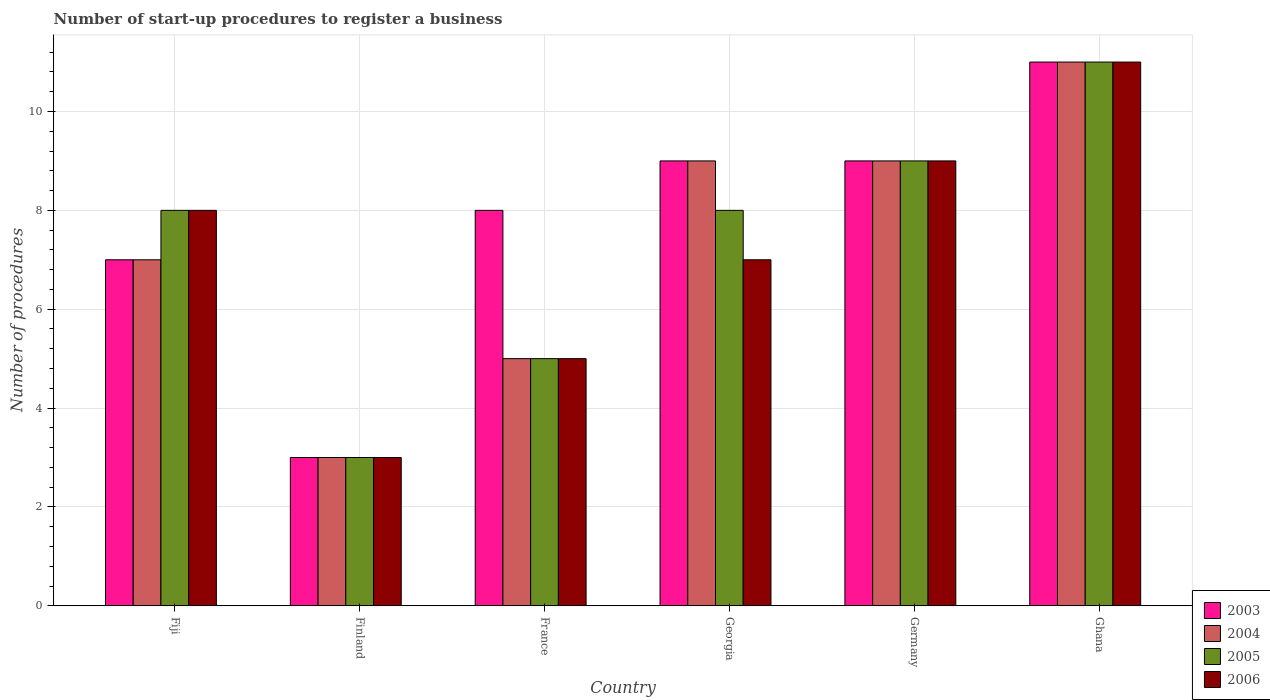How many groups of bars are there?
Offer a very short reply. 6. Are the number of bars per tick equal to the number of legend labels?
Give a very brief answer. Yes. What is the number of procedures required to register a business in 2004 in France?
Provide a short and direct response. 5. In which country was the number of procedures required to register a business in 2003 minimum?
Offer a very short reply. Finland. What is the total number of procedures required to register a business in 2006 in the graph?
Provide a succinct answer. 43. What is the difference between the number of procedures required to register a business in 2006 in Germany and the number of procedures required to register a business in 2003 in Fiji?
Give a very brief answer. 2. What is the average number of procedures required to register a business in 2003 per country?
Your response must be concise. 7.83. What is the difference between the number of procedures required to register a business of/in 2004 and number of procedures required to register a business of/in 2003 in Georgia?
Ensure brevity in your answer.  0. In how many countries, is the number of procedures required to register a business in 2006 greater than 0.8?
Your response must be concise. 6. What is the ratio of the number of procedures required to register a business in 2006 in Fiji to that in Germany?
Keep it short and to the point. 0.89. Is the number of procedures required to register a business in 2005 in Fiji less than that in Germany?
Offer a terse response. Yes. What is the difference between the highest and the lowest number of procedures required to register a business in 2005?
Provide a succinct answer. 8. Is the sum of the number of procedures required to register a business in 2006 in France and Georgia greater than the maximum number of procedures required to register a business in 2003 across all countries?
Keep it short and to the point. Yes. Is it the case that in every country, the sum of the number of procedures required to register a business in 2006 and number of procedures required to register a business in 2003 is greater than the sum of number of procedures required to register a business in 2004 and number of procedures required to register a business in 2005?
Keep it short and to the point. No. What does the 2nd bar from the left in Germany represents?
Make the answer very short. 2004. How many bars are there?
Make the answer very short. 24. What is the difference between two consecutive major ticks on the Y-axis?
Give a very brief answer. 2. Are the values on the major ticks of Y-axis written in scientific E-notation?
Give a very brief answer. No. How many legend labels are there?
Your response must be concise. 4. How are the legend labels stacked?
Provide a short and direct response. Vertical. What is the title of the graph?
Your response must be concise. Number of start-up procedures to register a business. Does "1968" appear as one of the legend labels in the graph?
Offer a terse response. No. What is the label or title of the Y-axis?
Your answer should be very brief. Number of procedures. What is the Number of procedures of 2003 in Fiji?
Your response must be concise. 7. What is the Number of procedures of 2006 in Fiji?
Give a very brief answer. 8. What is the Number of procedures of 2004 in Finland?
Your response must be concise. 3. What is the Number of procedures in 2003 in France?
Offer a very short reply. 8. What is the Number of procedures in 2004 in France?
Give a very brief answer. 5. What is the Number of procedures of 2005 in France?
Your answer should be very brief. 5. What is the Number of procedures in 2005 in Georgia?
Your response must be concise. 8. What is the Number of procedures of 2006 in Georgia?
Offer a terse response. 7. What is the Number of procedures in 2004 in Germany?
Provide a succinct answer. 9. What is the Number of procedures in 2003 in Ghana?
Your answer should be compact. 11. Across all countries, what is the maximum Number of procedures of 2003?
Offer a terse response. 11. Across all countries, what is the maximum Number of procedures in 2005?
Your answer should be very brief. 11. Across all countries, what is the maximum Number of procedures of 2006?
Provide a short and direct response. 11. Across all countries, what is the minimum Number of procedures in 2003?
Provide a short and direct response. 3. Across all countries, what is the minimum Number of procedures in 2004?
Your answer should be very brief. 3. Across all countries, what is the minimum Number of procedures of 2005?
Keep it short and to the point. 3. Across all countries, what is the minimum Number of procedures of 2006?
Your response must be concise. 3. What is the total Number of procedures in 2006 in the graph?
Ensure brevity in your answer.  43. What is the difference between the Number of procedures in 2004 in Fiji and that in Finland?
Give a very brief answer. 4. What is the difference between the Number of procedures of 2005 in Fiji and that in Finland?
Keep it short and to the point. 5. What is the difference between the Number of procedures in 2006 in Fiji and that in Finland?
Your answer should be compact. 5. What is the difference between the Number of procedures in 2004 in Fiji and that in France?
Your answer should be very brief. 2. What is the difference between the Number of procedures of 2005 in Fiji and that in France?
Provide a short and direct response. 3. What is the difference between the Number of procedures in 2006 in Fiji and that in France?
Ensure brevity in your answer.  3. What is the difference between the Number of procedures of 2004 in Fiji and that in Georgia?
Your response must be concise. -2. What is the difference between the Number of procedures of 2006 in Fiji and that in Georgia?
Keep it short and to the point. 1. What is the difference between the Number of procedures in 2005 in Fiji and that in Germany?
Your answer should be compact. -1. What is the difference between the Number of procedures of 2004 in Fiji and that in Ghana?
Keep it short and to the point. -4. What is the difference between the Number of procedures of 2005 in Fiji and that in Ghana?
Offer a terse response. -3. What is the difference between the Number of procedures in 2004 in Finland and that in France?
Keep it short and to the point. -2. What is the difference between the Number of procedures of 2005 in Finland and that in France?
Offer a very short reply. -2. What is the difference between the Number of procedures in 2003 in Finland and that in Georgia?
Provide a short and direct response. -6. What is the difference between the Number of procedures in 2005 in Finland and that in Georgia?
Ensure brevity in your answer.  -5. What is the difference between the Number of procedures of 2006 in Finland and that in Georgia?
Offer a terse response. -4. What is the difference between the Number of procedures of 2003 in Finland and that in Germany?
Provide a succinct answer. -6. What is the difference between the Number of procedures in 2004 in Finland and that in Ghana?
Offer a very short reply. -8. What is the difference between the Number of procedures in 2003 in France and that in Georgia?
Give a very brief answer. -1. What is the difference between the Number of procedures in 2004 in France and that in Georgia?
Ensure brevity in your answer.  -4. What is the difference between the Number of procedures of 2005 in France and that in Georgia?
Provide a short and direct response. -3. What is the difference between the Number of procedures of 2004 in France and that in Germany?
Your answer should be very brief. -4. What is the difference between the Number of procedures in 2006 in France and that in Germany?
Ensure brevity in your answer.  -4. What is the difference between the Number of procedures of 2003 in France and that in Ghana?
Ensure brevity in your answer.  -3. What is the difference between the Number of procedures of 2004 in France and that in Ghana?
Ensure brevity in your answer.  -6. What is the difference between the Number of procedures in 2005 in France and that in Ghana?
Offer a very short reply. -6. What is the difference between the Number of procedures in 2006 in France and that in Ghana?
Keep it short and to the point. -6. What is the difference between the Number of procedures in 2003 in Georgia and that in Germany?
Give a very brief answer. 0. What is the difference between the Number of procedures in 2005 in Georgia and that in Germany?
Give a very brief answer. -1. What is the difference between the Number of procedures of 2006 in Georgia and that in Germany?
Ensure brevity in your answer.  -2. What is the difference between the Number of procedures of 2003 in Georgia and that in Ghana?
Provide a short and direct response. -2. What is the difference between the Number of procedures in 2004 in Georgia and that in Ghana?
Ensure brevity in your answer.  -2. What is the difference between the Number of procedures in 2004 in Germany and that in Ghana?
Your answer should be compact. -2. What is the difference between the Number of procedures of 2005 in Germany and that in Ghana?
Provide a succinct answer. -2. What is the difference between the Number of procedures in 2003 in Fiji and the Number of procedures in 2004 in Finland?
Provide a succinct answer. 4. What is the difference between the Number of procedures of 2003 in Fiji and the Number of procedures of 2005 in Finland?
Your answer should be compact. 4. What is the difference between the Number of procedures in 2004 in Fiji and the Number of procedures in 2005 in Finland?
Give a very brief answer. 4. What is the difference between the Number of procedures of 2004 in Fiji and the Number of procedures of 2006 in Finland?
Your answer should be compact. 4. What is the difference between the Number of procedures of 2003 in Fiji and the Number of procedures of 2004 in France?
Keep it short and to the point. 2. What is the difference between the Number of procedures in 2003 in Fiji and the Number of procedures in 2006 in France?
Offer a very short reply. 2. What is the difference between the Number of procedures of 2005 in Fiji and the Number of procedures of 2006 in France?
Give a very brief answer. 3. What is the difference between the Number of procedures in 2003 in Fiji and the Number of procedures in 2004 in Georgia?
Give a very brief answer. -2. What is the difference between the Number of procedures of 2003 in Fiji and the Number of procedures of 2006 in Georgia?
Your response must be concise. 0. What is the difference between the Number of procedures in 2004 in Fiji and the Number of procedures in 2006 in Georgia?
Your answer should be compact. 0. What is the difference between the Number of procedures in 2005 in Fiji and the Number of procedures in 2006 in Georgia?
Offer a terse response. 1. What is the difference between the Number of procedures of 2003 in Fiji and the Number of procedures of 2004 in Germany?
Ensure brevity in your answer.  -2. What is the difference between the Number of procedures in 2004 in Fiji and the Number of procedures in 2005 in Germany?
Provide a short and direct response. -2. What is the difference between the Number of procedures in 2003 in Fiji and the Number of procedures in 2005 in Ghana?
Provide a succinct answer. -4. What is the difference between the Number of procedures of 2004 in Fiji and the Number of procedures of 2006 in Ghana?
Offer a very short reply. -4. What is the difference between the Number of procedures in 2004 in Finland and the Number of procedures in 2005 in Georgia?
Provide a short and direct response. -5. What is the difference between the Number of procedures of 2003 in Finland and the Number of procedures of 2006 in Germany?
Your answer should be compact. -6. What is the difference between the Number of procedures in 2004 in Finland and the Number of procedures in 2006 in Germany?
Offer a terse response. -6. What is the difference between the Number of procedures in 2003 in Finland and the Number of procedures in 2004 in Ghana?
Your answer should be compact. -8. What is the difference between the Number of procedures of 2003 in Finland and the Number of procedures of 2005 in Ghana?
Provide a succinct answer. -8. What is the difference between the Number of procedures of 2003 in Finland and the Number of procedures of 2006 in Ghana?
Offer a terse response. -8. What is the difference between the Number of procedures in 2004 in Finland and the Number of procedures in 2005 in Ghana?
Your answer should be compact. -8. What is the difference between the Number of procedures of 2005 in Finland and the Number of procedures of 2006 in Ghana?
Your answer should be compact. -8. What is the difference between the Number of procedures in 2003 in France and the Number of procedures in 2004 in Georgia?
Provide a short and direct response. -1. What is the difference between the Number of procedures in 2003 in France and the Number of procedures in 2006 in Georgia?
Your answer should be very brief. 1. What is the difference between the Number of procedures of 2004 in France and the Number of procedures of 2006 in Georgia?
Offer a very short reply. -2. What is the difference between the Number of procedures of 2003 in France and the Number of procedures of 2006 in Germany?
Provide a succinct answer. -1. What is the difference between the Number of procedures in 2004 in France and the Number of procedures in 2005 in Germany?
Offer a terse response. -4. What is the difference between the Number of procedures in 2003 in France and the Number of procedures in 2004 in Ghana?
Provide a succinct answer. -3. What is the difference between the Number of procedures in 2003 in France and the Number of procedures in 2005 in Ghana?
Offer a very short reply. -3. What is the difference between the Number of procedures in 2003 in France and the Number of procedures in 2006 in Ghana?
Offer a very short reply. -3. What is the difference between the Number of procedures in 2004 in France and the Number of procedures in 2005 in Ghana?
Give a very brief answer. -6. What is the difference between the Number of procedures of 2003 in Georgia and the Number of procedures of 2004 in Germany?
Provide a succinct answer. 0. What is the difference between the Number of procedures in 2004 in Georgia and the Number of procedures in 2006 in Germany?
Your response must be concise. 0. What is the difference between the Number of procedures of 2005 in Georgia and the Number of procedures of 2006 in Germany?
Your response must be concise. -1. What is the difference between the Number of procedures of 2003 in Georgia and the Number of procedures of 2004 in Ghana?
Your answer should be very brief. -2. What is the difference between the Number of procedures in 2005 in Georgia and the Number of procedures in 2006 in Ghana?
Your answer should be very brief. -3. What is the difference between the Number of procedures in 2003 in Germany and the Number of procedures in 2006 in Ghana?
Keep it short and to the point. -2. What is the difference between the Number of procedures of 2004 in Germany and the Number of procedures of 2006 in Ghana?
Your response must be concise. -2. What is the difference between the Number of procedures in 2005 in Germany and the Number of procedures in 2006 in Ghana?
Give a very brief answer. -2. What is the average Number of procedures of 2003 per country?
Your response must be concise. 7.83. What is the average Number of procedures of 2004 per country?
Provide a short and direct response. 7.33. What is the average Number of procedures in 2005 per country?
Provide a succinct answer. 7.33. What is the average Number of procedures in 2006 per country?
Keep it short and to the point. 7.17. What is the difference between the Number of procedures of 2003 and Number of procedures of 2004 in Fiji?
Offer a very short reply. 0. What is the difference between the Number of procedures in 2003 and Number of procedures in 2005 in Fiji?
Offer a very short reply. -1. What is the difference between the Number of procedures of 2003 and Number of procedures of 2006 in Fiji?
Offer a terse response. -1. What is the difference between the Number of procedures in 2004 and Number of procedures in 2005 in Fiji?
Offer a very short reply. -1. What is the difference between the Number of procedures in 2005 and Number of procedures in 2006 in Fiji?
Provide a short and direct response. 0. What is the difference between the Number of procedures in 2003 and Number of procedures in 2006 in Finland?
Keep it short and to the point. 0. What is the difference between the Number of procedures in 2004 and Number of procedures in 2005 in Finland?
Provide a succinct answer. 0. What is the difference between the Number of procedures of 2004 and Number of procedures of 2006 in Finland?
Keep it short and to the point. 0. What is the difference between the Number of procedures of 2005 and Number of procedures of 2006 in Finland?
Your response must be concise. 0. What is the difference between the Number of procedures in 2003 and Number of procedures in 2004 in France?
Your answer should be compact. 3. What is the difference between the Number of procedures in 2003 and Number of procedures in 2005 in France?
Ensure brevity in your answer.  3. What is the difference between the Number of procedures in 2003 and Number of procedures in 2006 in France?
Offer a terse response. 3. What is the difference between the Number of procedures in 2004 and Number of procedures in 2005 in France?
Provide a short and direct response. 0. What is the difference between the Number of procedures in 2005 and Number of procedures in 2006 in France?
Ensure brevity in your answer.  0. What is the difference between the Number of procedures in 2003 and Number of procedures in 2004 in Georgia?
Make the answer very short. 0. What is the difference between the Number of procedures of 2003 and Number of procedures of 2006 in Georgia?
Give a very brief answer. 2. What is the difference between the Number of procedures of 2004 and Number of procedures of 2005 in Georgia?
Provide a succinct answer. 1. What is the difference between the Number of procedures in 2003 and Number of procedures in 2004 in Germany?
Provide a succinct answer. 0. What is the difference between the Number of procedures of 2004 and Number of procedures of 2005 in Germany?
Your response must be concise. 0. What is the difference between the Number of procedures of 2003 and Number of procedures of 2004 in Ghana?
Make the answer very short. 0. What is the difference between the Number of procedures in 2003 and Number of procedures in 2006 in Ghana?
Offer a terse response. 0. What is the difference between the Number of procedures of 2004 and Number of procedures of 2005 in Ghana?
Ensure brevity in your answer.  0. What is the difference between the Number of procedures in 2004 and Number of procedures in 2006 in Ghana?
Provide a short and direct response. 0. What is the ratio of the Number of procedures of 2003 in Fiji to that in Finland?
Keep it short and to the point. 2.33. What is the ratio of the Number of procedures in 2004 in Fiji to that in Finland?
Provide a succinct answer. 2.33. What is the ratio of the Number of procedures in 2005 in Fiji to that in Finland?
Offer a very short reply. 2.67. What is the ratio of the Number of procedures in 2006 in Fiji to that in Finland?
Provide a succinct answer. 2.67. What is the ratio of the Number of procedures in 2004 in Fiji to that in Georgia?
Your response must be concise. 0.78. What is the ratio of the Number of procedures of 2005 in Fiji to that in Georgia?
Give a very brief answer. 1. What is the ratio of the Number of procedures in 2006 in Fiji to that in Georgia?
Provide a succinct answer. 1.14. What is the ratio of the Number of procedures of 2003 in Fiji to that in Ghana?
Give a very brief answer. 0.64. What is the ratio of the Number of procedures in 2004 in Fiji to that in Ghana?
Your response must be concise. 0.64. What is the ratio of the Number of procedures in 2005 in Fiji to that in Ghana?
Keep it short and to the point. 0.73. What is the ratio of the Number of procedures of 2006 in Fiji to that in Ghana?
Make the answer very short. 0.73. What is the ratio of the Number of procedures in 2003 in Finland to that in France?
Your answer should be compact. 0.38. What is the ratio of the Number of procedures of 2005 in Finland to that in France?
Offer a terse response. 0.6. What is the ratio of the Number of procedures in 2003 in Finland to that in Georgia?
Your answer should be compact. 0.33. What is the ratio of the Number of procedures of 2006 in Finland to that in Georgia?
Keep it short and to the point. 0.43. What is the ratio of the Number of procedures of 2003 in Finland to that in Germany?
Your answer should be very brief. 0.33. What is the ratio of the Number of procedures of 2005 in Finland to that in Germany?
Your answer should be compact. 0.33. What is the ratio of the Number of procedures of 2006 in Finland to that in Germany?
Your answer should be very brief. 0.33. What is the ratio of the Number of procedures in 2003 in Finland to that in Ghana?
Provide a short and direct response. 0.27. What is the ratio of the Number of procedures of 2004 in Finland to that in Ghana?
Make the answer very short. 0.27. What is the ratio of the Number of procedures in 2005 in Finland to that in Ghana?
Your answer should be very brief. 0.27. What is the ratio of the Number of procedures of 2006 in Finland to that in Ghana?
Ensure brevity in your answer.  0.27. What is the ratio of the Number of procedures in 2004 in France to that in Georgia?
Your response must be concise. 0.56. What is the ratio of the Number of procedures of 2003 in France to that in Germany?
Provide a short and direct response. 0.89. What is the ratio of the Number of procedures of 2004 in France to that in Germany?
Make the answer very short. 0.56. What is the ratio of the Number of procedures of 2005 in France to that in Germany?
Give a very brief answer. 0.56. What is the ratio of the Number of procedures in 2006 in France to that in Germany?
Keep it short and to the point. 0.56. What is the ratio of the Number of procedures in 2003 in France to that in Ghana?
Make the answer very short. 0.73. What is the ratio of the Number of procedures in 2004 in France to that in Ghana?
Make the answer very short. 0.45. What is the ratio of the Number of procedures of 2005 in France to that in Ghana?
Ensure brevity in your answer.  0.45. What is the ratio of the Number of procedures of 2006 in France to that in Ghana?
Your answer should be very brief. 0.45. What is the ratio of the Number of procedures of 2004 in Georgia to that in Germany?
Your answer should be compact. 1. What is the ratio of the Number of procedures in 2003 in Georgia to that in Ghana?
Ensure brevity in your answer.  0.82. What is the ratio of the Number of procedures in 2004 in Georgia to that in Ghana?
Your response must be concise. 0.82. What is the ratio of the Number of procedures of 2005 in Georgia to that in Ghana?
Ensure brevity in your answer.  0.73. What is the ratio of the Number of procedures in 2006 in Georgia to that in Ghana?
Ensure brevity in your answer.  0.64. What is the ratio of the Number of procedures of 2003 in Germany to that in Ghana?
Make the answer very short. 0.82. What is the ratio of the Number of procedures in 2004 in Germany to that in Ghana?
Provide a succinct answer. 0.82. What is the ratio of the Number of procedures of 2005 in Germany to that in Ghana?
Provide a succinct answer. 0.82. What is the ratio of the Number of procedures of 2006 in Germany to that in Ghana?
Ensure brevity in your answer.  0.82. What is the difference between the highest and the second highest Number of procedures in 2003?
Your response must be concise. 2. What is the difference between the highest and the second highest Number of procedures of 2004?
Your response must be concise. 2. What is the difference between the highest and the second highest Number of procedures of 2005?
Ensure brevity in your answer.  2. What is the difference between the highest and the second highest Number of procedures of 2006?
Make the answer very short. 2. What is the difference between the highest and the lowest Number of procedures of 2003?
Your answer should be very brief. 8. What is the difference between the highest and the lowest Number of procedures in 2005?
Offer a very short reply. 8. What is the difference between the highest and the lowest Number of procedures in 2006?
Give a very brief answer. 8. 